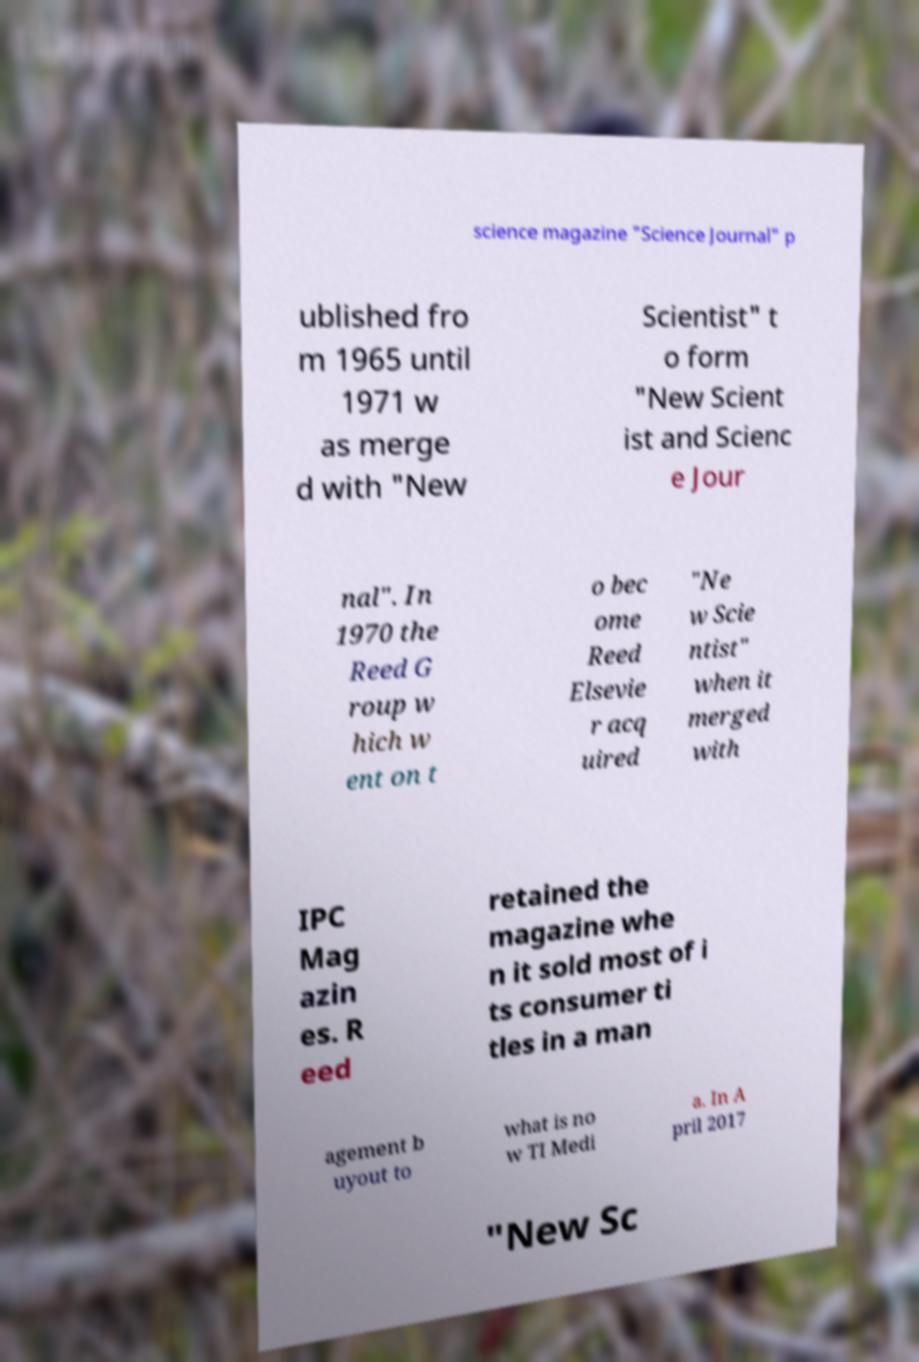Could you extract and type out the text from this image? science magazine "Science Journal" p ublished fro m 1965 until 1971 w as merge d with "New Scientist" t o form "New Scient ist and Scienc e Jour nal". In 1970 the Reed G roup w hich w ent on t o bec ome Reed Elsevie r acq uired "Ne w Scie ntist" when it merged with IPC Mag azin es. R eed retained the magazine whe n it sold most of i ts consumer ti tles in a man agement b uyout to what is no w TI Medi a. In A pril 2017 "New Sc 